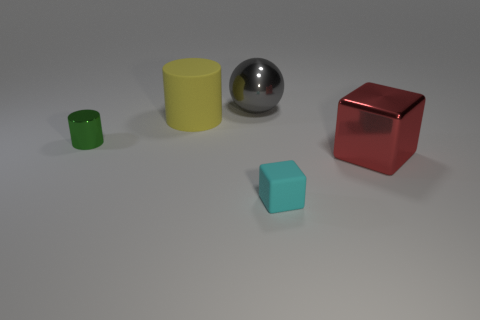There is a cylinder right of the small green thing; does it have the same color as the small block?
Keep it short and to the point. No. What number of other things are the same size as the green metallic object?
Your answer should be compact. 1. Do the large cylinder and the small block have the same material?
Your answer should be compact. Yes. There is a block left of the big thing on the right side of the gray sphere; what color is it?
Offer a terse response. Cyan. What size is the cyan rubber object that is the same shape as the red object?
Make the answer very short. Small. Is the color of the small metallic cylinder the same as the large shiny sphere?
Provide a short and direct response. No. There is a big gray sphere on the right side of the metallic object that is left of the big sphere; what number of large things are left of it?
Offer a terse response. 1. Is the number of tiny cyan cubes greater than the number of tiny red metallic objects?
Make the answer very short. Yes. What number of tiny blue spheres are there?
Keep it short and to the point. 0. There is a tiny object on the right side of the tiny object that is behind the large object that is in front of the big yellow cylinder; what is its shape?
Ensure brevity in your answer.  Cube. 